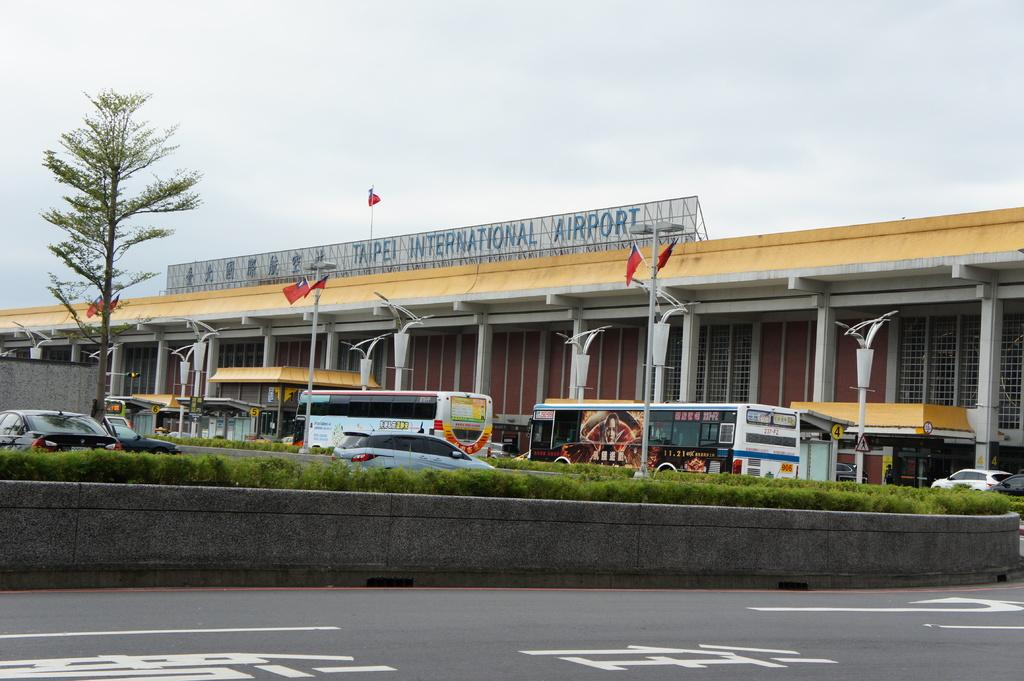What type of building is visible in the image? There is an airport building in the image. What can be seen on poles near the airport building? There are flags on poles in the image. What type of lighting is present in the image? There are pole lights in the image. What type of vehicles are present in the image? There are buses and cars in the image. What type of vegetation is visible in the image? There is a tree in the image. What is on the airport building? There is a flag on the airport building. How would you describe the sky in the image? The sky is cloudy in the image. What type of laborer is working on the crack in the image? There is no laborer or crack present in the image. What angle is the tree leaning at in the image? The tree is not leaning in the image; it is standing upright. 